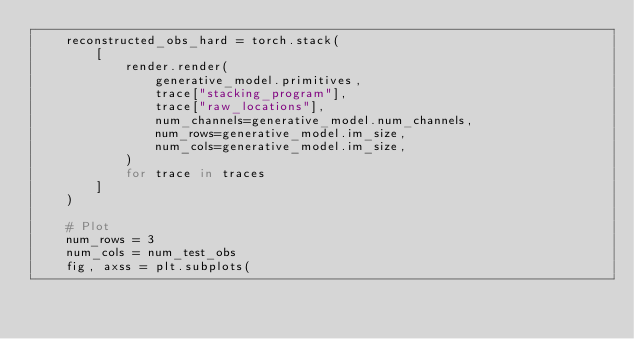Convert code to text. <code><loc_0><loc_0><loc_500><loc_500><_Python_>    reconstructed_obs_hard = torch.stack(
        [
            render.render(
                generative_model.primitives,
                trace["stacking_program"],
                trace["raw_locations"],
                num_channels=generative_model.num_channels,
                num_rows=generative_model.im_size,
                num_cols=generative_model.im_size,
            )
            for trace in traces
        ]
    )

    # Plot
    num_rows = 3
    num_cols = num_test_obs
    fig, axss = plt.subplots(</code> 